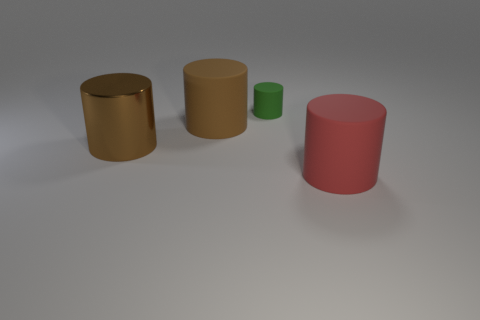Subtract all blue spheres. How many brown cylinders are left? 2 Add 3 small yellow rubber spheres. How many objects exist? 7 Subtract all tiny green matte cylinders. How many cylinders are left? 3 Subtract all red cylinders. How many cylinders are left? 3 Subtract 1 cylinders. How many cylinders are left? 3 Subtract all big cyan shiny cylinders. Subtract all large red cylinders. How many objects are left? 3 Add 2 brown objects. How many brown objects are left? 4 Add 3 large red cylinders. How many large red cylinders exist? 4 Subtract 0 brown cubes. How many objects are left? 4 Subtract all gray cylinders. Subtract all cyan spheres. How many cylinders are left? 4 